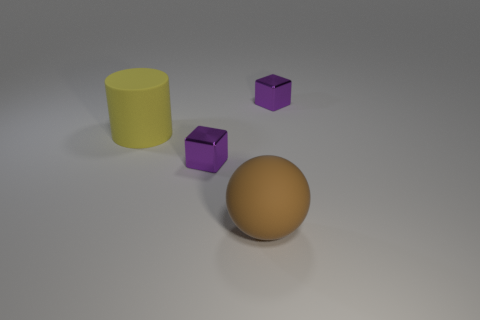There is a purple block that is to the right of the brown sphere; how big is it?
Provide a short and direct response. Small. Are there fewer tiny yellow shiny spheres than brown matte objects?
Make the answer very short. Yes. Are there any other rubber balls that have the same color as the rubber sphere?
Keep it short and to the point. No. What is the shape of the thing that is both left of the big ball and on the right side of the big matte cylinder?
Provide a short and direct response. Cube. There is a big yellow object left of the tiny shiny object in front of the big yellow matte object; what is its shape?
Ensure brevity in your answer.  Cylinder. Do the brown rubber thing and the yellow rubber object have the same shape?
Offer a very short reply. No. Does the cylinder have the same color as the large ball?
Make the answer very short. No. There is a small object in front of the big yellow cylinder left of the brown thing; what number of matte balls are to the right of it?
Your answer should be very brief. 1. There is another big object that is made of the same material as the large brown thing; what shape is it?
Provide a succinct answer. Cylinder. There is a big ball in front of the purple metal cube behind the large matte thing to the left of the brown rubber sphere; what is it made of?
Provide a succinct answer. Rubber. 